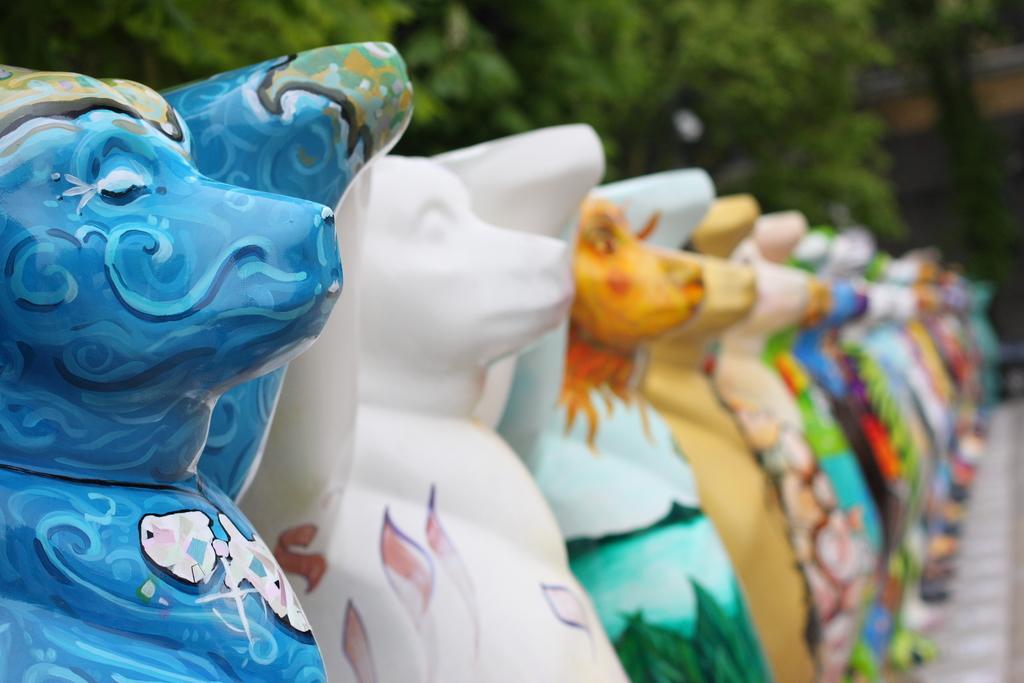Can you describe this image briefly? In this picture we can see a few colorful objects. There are some trees in the background. We can see a blur background view. 